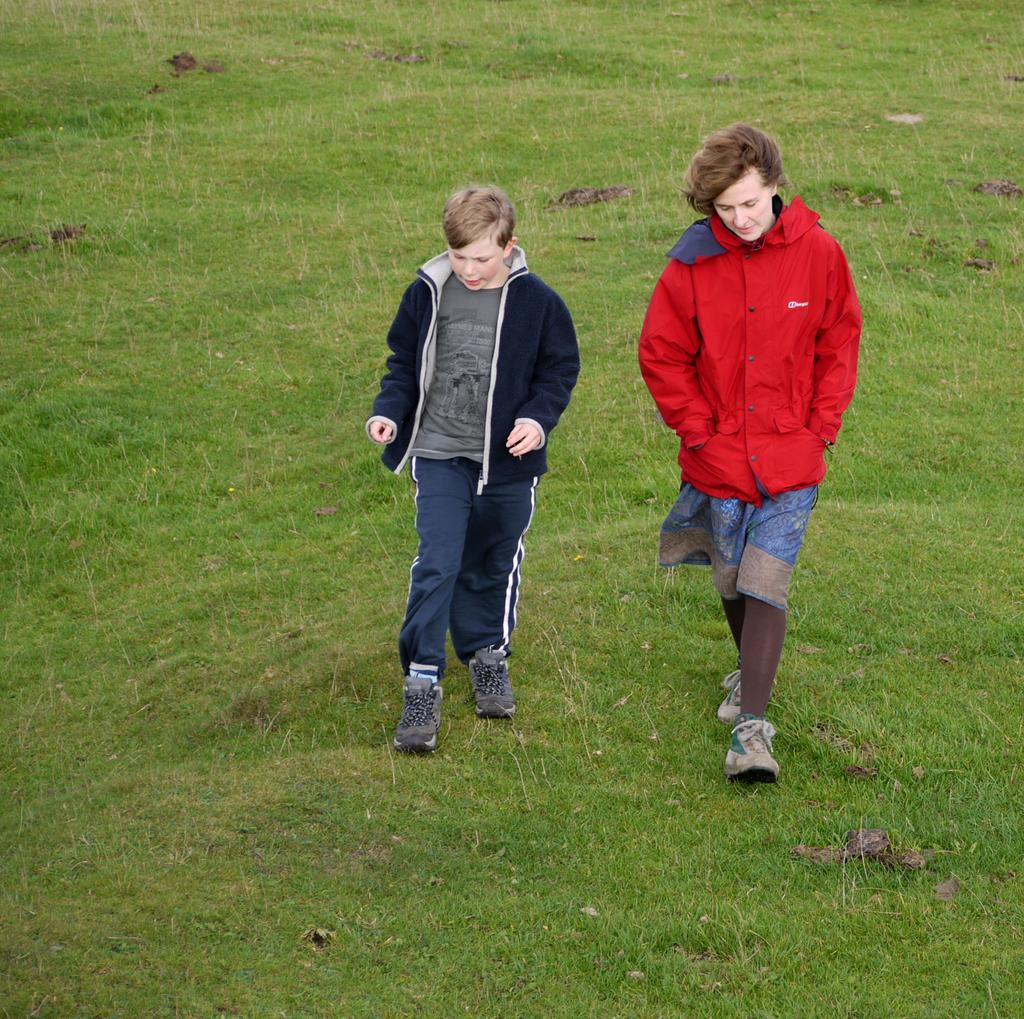Can you describe this image briefly? In this image there is a woman and a boy walking on the ground. There is grass on the ground. 